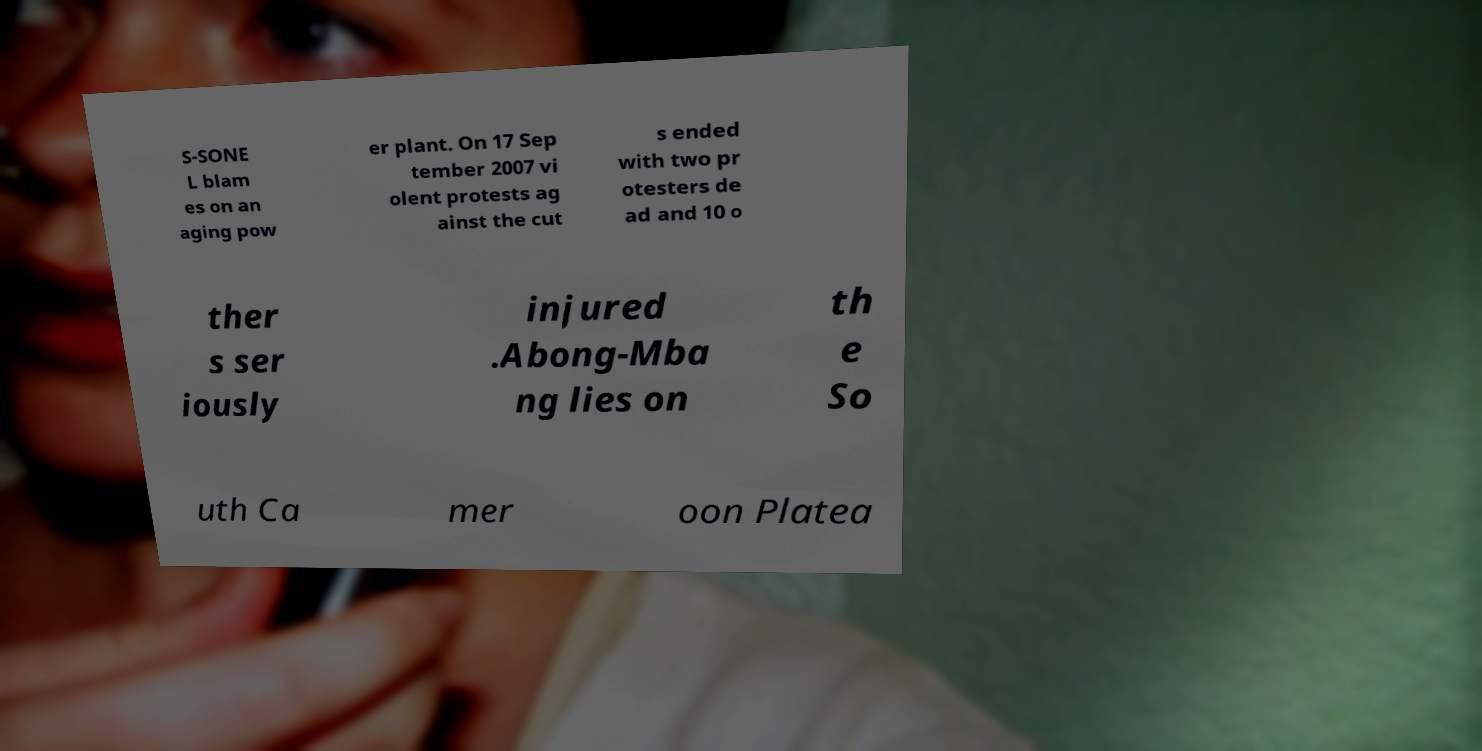Please read and relay the text visible in this image. What does it say? S-SONE L blam es on an aging pow er plant. On 17 Sep tember 2007 vi olent protests ag ainst the cut s ended with two pr otesters de ad and 10 o ther s ser iously injured .Abong-Mba ng lies on th e So uth Ca mer oon Platea 